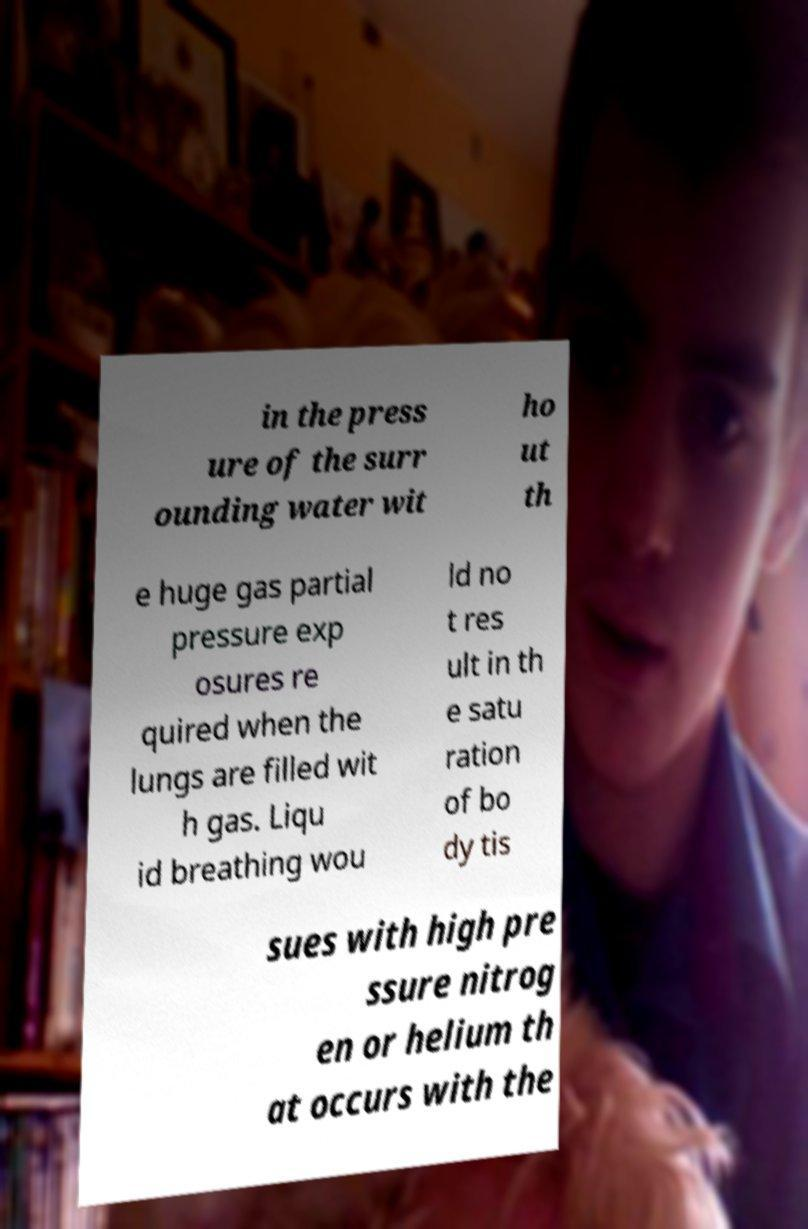Please identify and transcribe the text found in this image. in the press ure of the surr ounding water wit ho ut th e huge gas partial pressure exp osures re quired when the lungs are filled wit h gas. Liqu id breathing wou ld no t res ult in th e satu ration of bo dy tis sues with high pre ssure nitrog en or helium th at occurs with the 